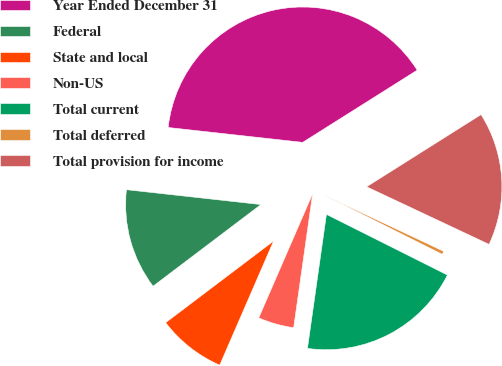Convert chart to OTSL. <chart><loc_0><loc_0><loc_500><loc_500><pie_chart><fcel>Year Ended December 31<fcel>Federal<fcel>State and local<fcel>Non-US<fcel>Total current<fcel>Total deferred<fcel>Total provision for income<nl><fcel>39.29%<fcel>12.06%<fcel>8.17%<fcel>4.28%<fcel>19.84%<fcel>0.4%<fcel>15.95%<nl></chart> 